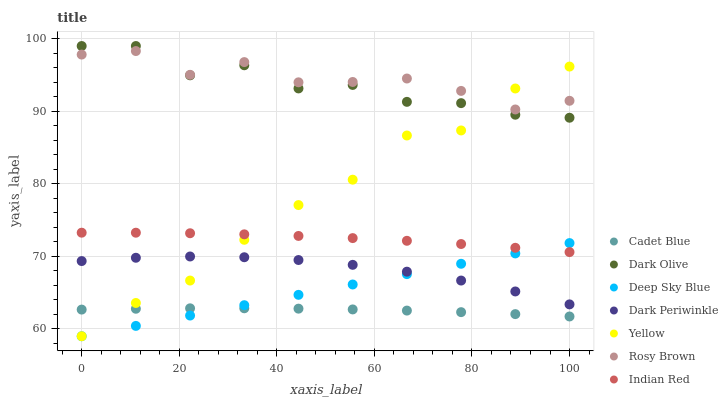Does Cadet Blue have the minimum area under the curve?
Answer yes or no. Yes. Does Rosy Brown have the maximum area under the curve?
Answer yes or no. Yes. Does Indian Red have the minimum area under the curve?
Answer yes or no. No. Does Indian Red have the maximum area under the curve?
Answer yes or no. No. Is Deep Sky Blue the smoothest?
Answer yes or no. Yes. Is Dark Olive the roughest?
Answer yes or no. Yes. Is Indian Red the smoothest?
Answer yes or no. No. Is Indian Red the roughest?
Answer yes or no. No. Does Yellow have the lowest value?
Answer yes or no. Yes. Does Indian Red have the lowest value?
Answer yes or no. No. Does Dark Olive have the highest value?
Answer yes or no. Yes. Does Indian Red have the highest value?
Answer yes or no. No. Is Cadet Blue less than Dark Periwinkle?
Answer yes or no. Yes. Is Dark Olive greater than Deep Sky Blue?
Answer yes or no. Yes. Does Yellow intersect Cadet Blue?
Answer yes or no. Yes. Is Yellow less than Cadet Blue?
Answer yes or no. No. Is Yellow greater than Cadet Blue?
Answer yes or no. No. Does Cadet Blue intersect Dark Periwinkle?
Answer yes or no. No. 